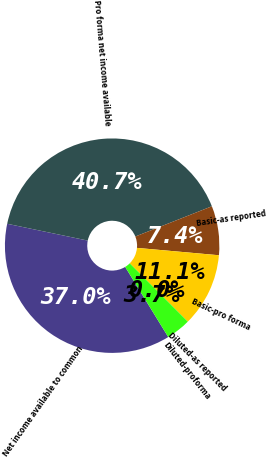<chart> <loc_0><loc_0><loc_500><loc_500><pie_chart><fcel>Net income available to common<fcel>Pro forma net income available<fcel>Basic-as reported<fcel>Basic-pro forma<fcel>Diluted-as reported<fcel>Diluted-proforma<nl><fcel>37.04%<fcel>40.74%<fcel>7.41%<fcel>11.11%<fcel>0.0%<fcel>3.7%<nl></chart> 